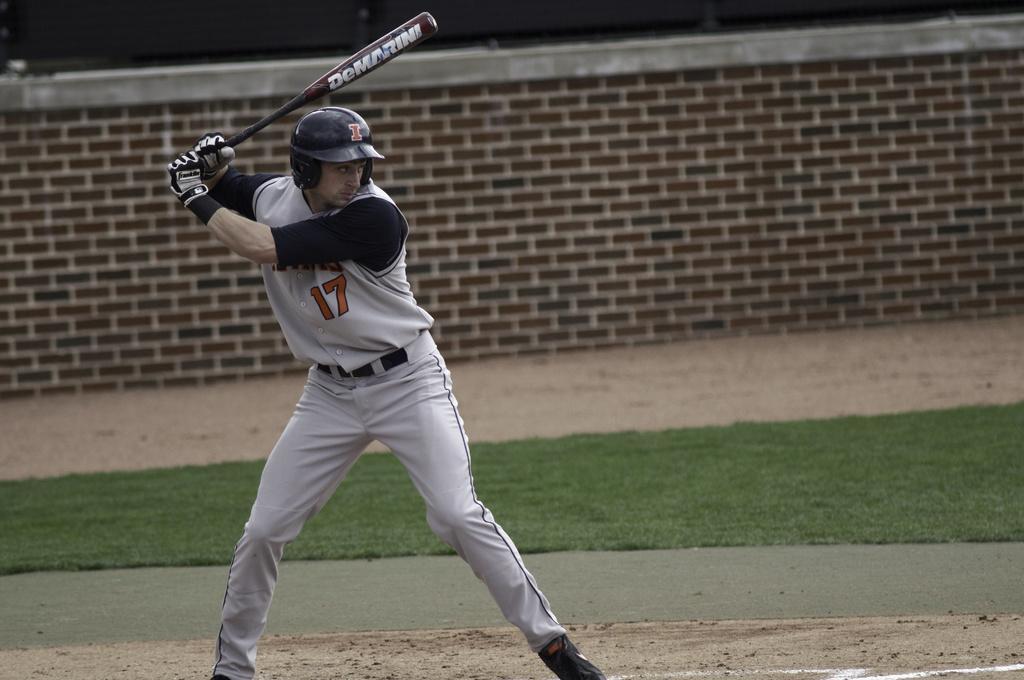How would you summarize this image in a sentence or two? In this picture we can see a man is standing and holding a baseball bat, he is wearing a helmet, gloves and shoes, at the bottom there is grass, in the background we can see a wall. 